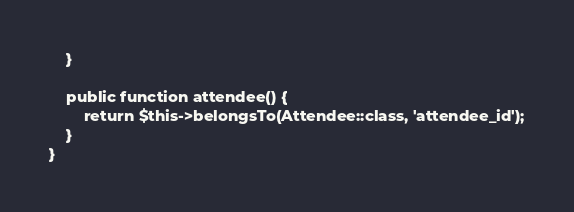Convert code to text. <code><loc_0><loc_0><loc_500><loc_500><_PHP_>    }

    public function attendee() {
        return $this->belongsTo(Attendee::class, 'attendee_id');
    }
}
</code> 